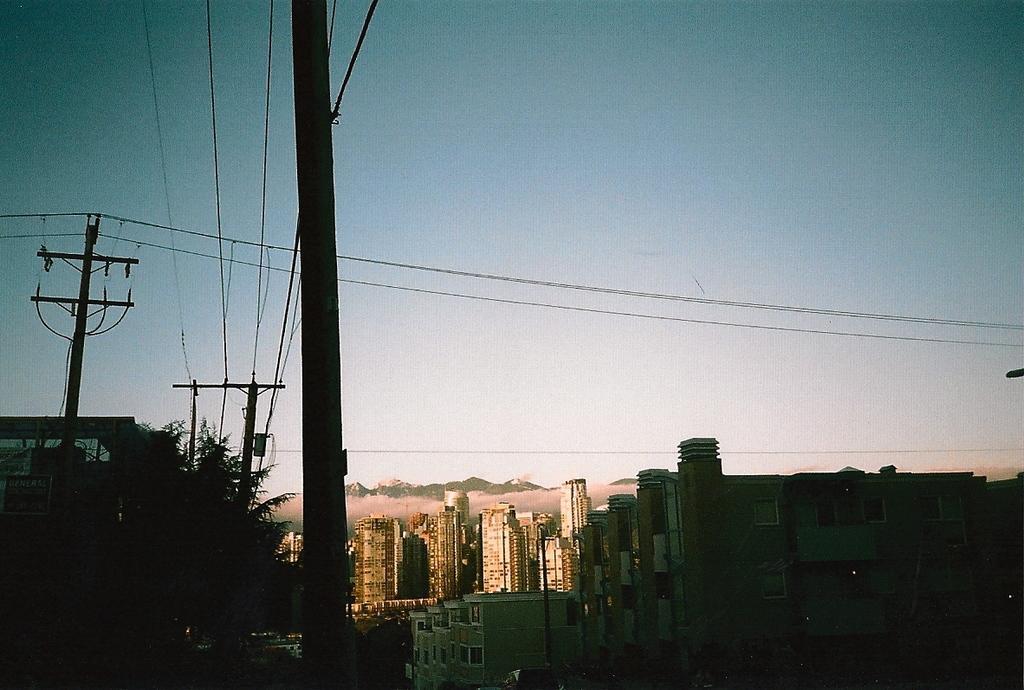Please provide a concise description of this image. In this picture we can see some buildings in the front. On the left side there is a tree, electric pole and cables. On the top there is a sky. 